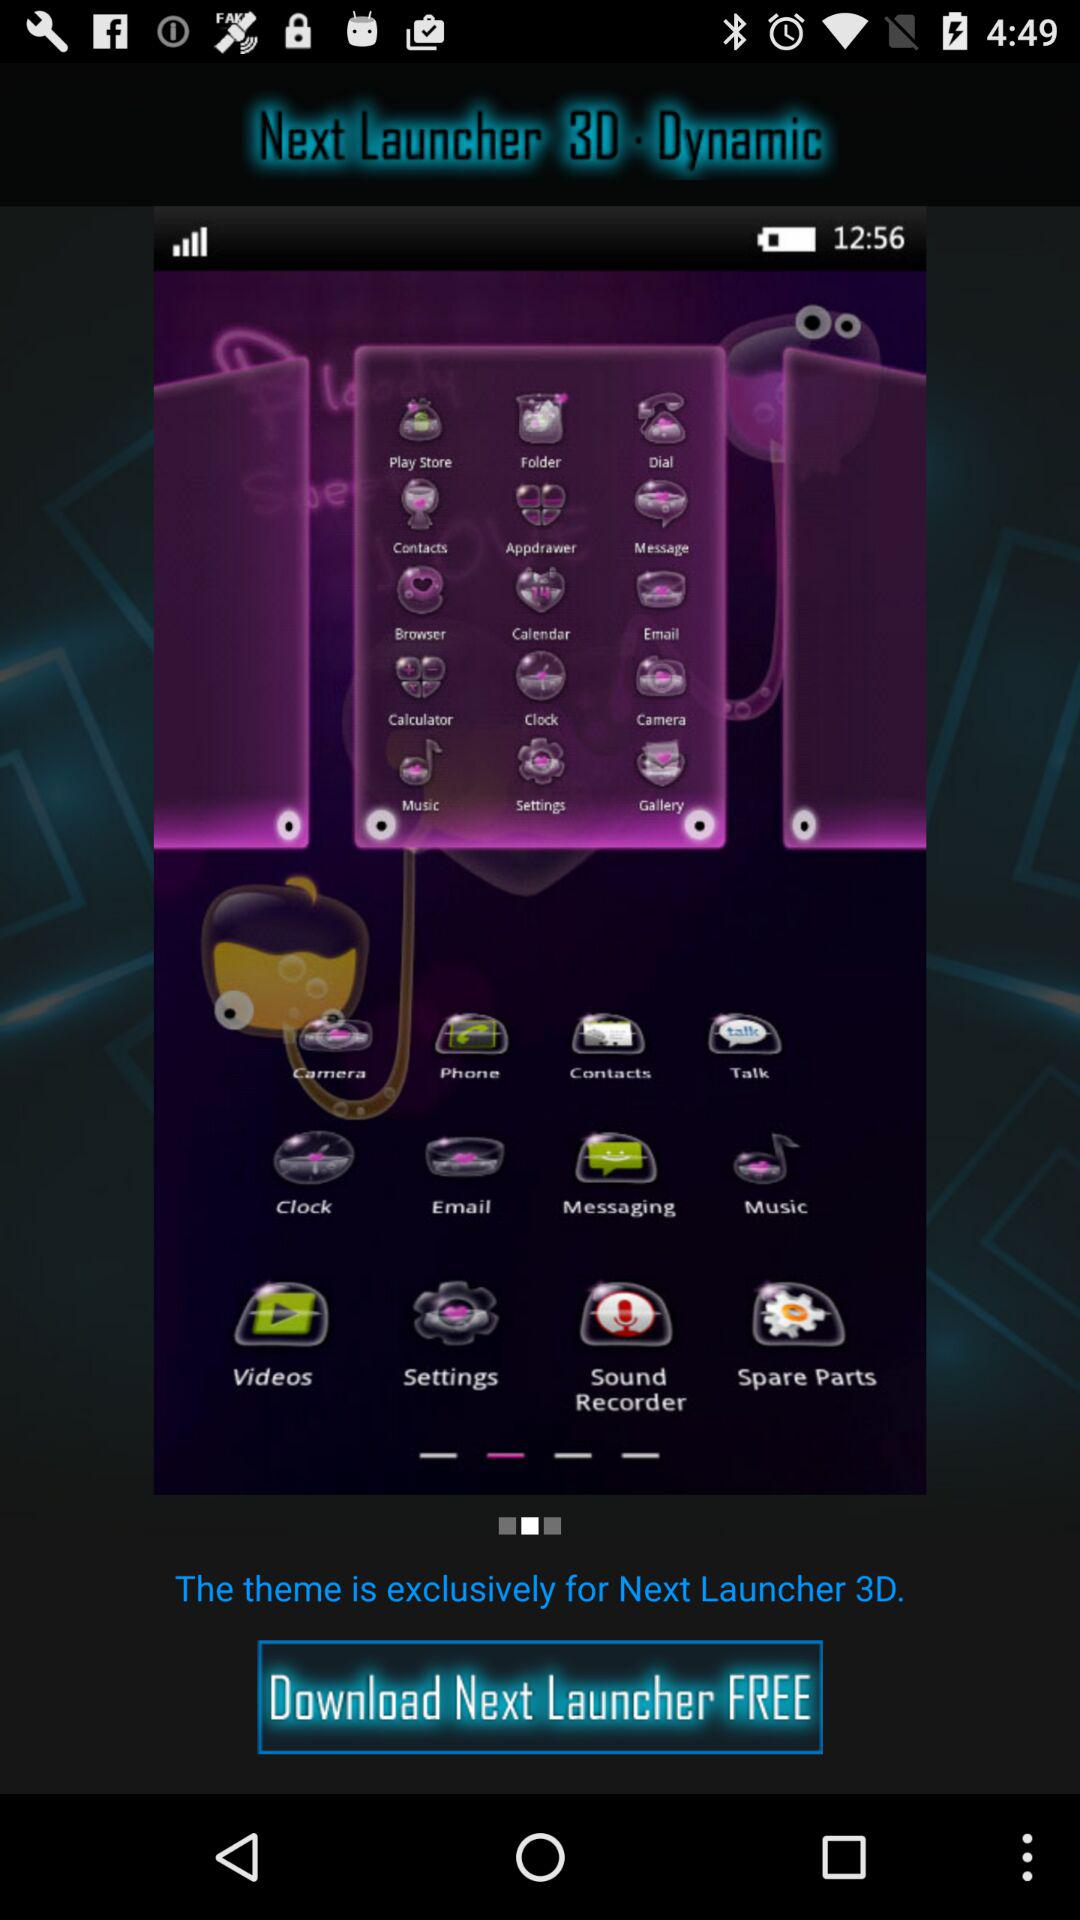What is the application name? The application name is "Next Launcher 3D Dynamic". 